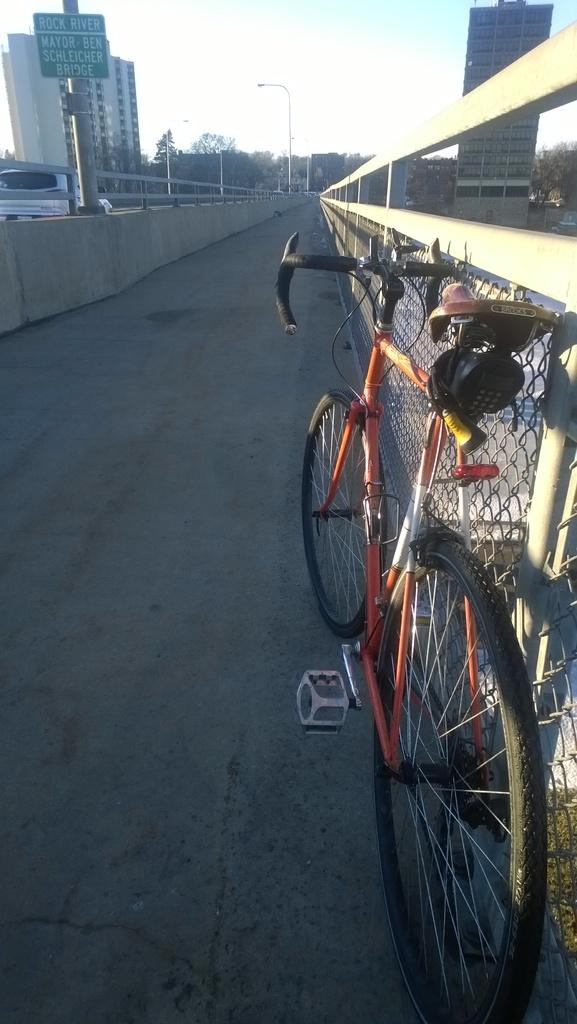What structure can be seen in the image connecting two buildings? A: There is a bridge in the image that connects two buildings. What is located on the bridge in the image? There is a cycle on the bridge. What is present in the top left corner of the image? There is a board in the top left of the image. What can be seen at the top of the image? The sky is visible at the top of the image. Can you tell me how many firemen are visible on the bridge in the image? There are no firemen present in the image; it only shows a bridge, a cycle, a board, and the sky. What type of letters are being written by the servant in the image? There is no servant or letter-writing activity present in the image. 